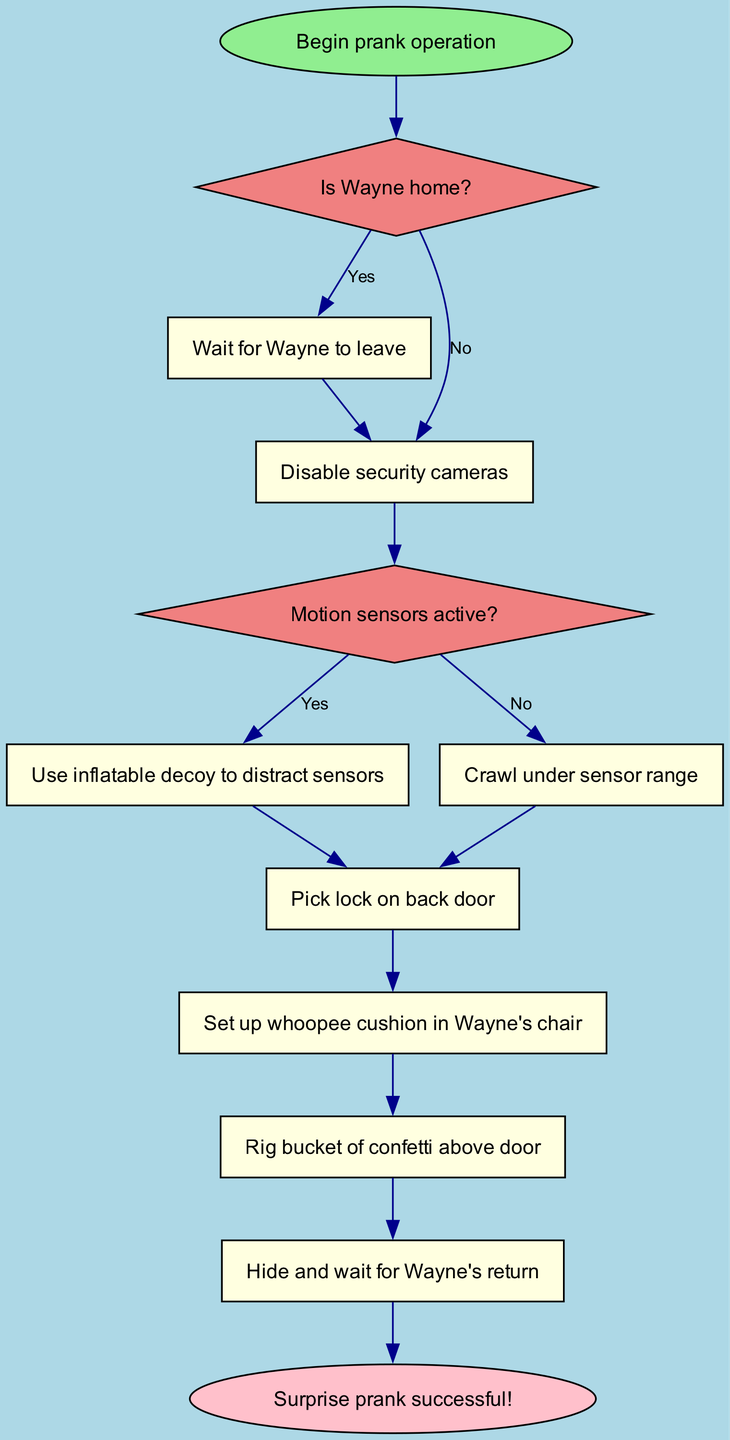What is the first action to take if Wayne is home? According to the flowchart, if Wayne is home, it leads to the first decision where the answer is 'Yes'. The next action indicated is to 'Wait for Wayne to leave'.
Answer: Wait for Wayne to leave What action comes after disabling security cameras? After the action of disabling security cameras, the flowchart directs to the second decision node, which asks if motion sensors are active. Therefore, the action that comes after is 'Disable security cameras'.
Answer: Disable security cameras How many action nodes are present in the flowchart? Upon counting the nodes in the diagram designated as actions, we find eight action nodes identified sequentially within the flowchart.
Answer: Eight What happens if motion sensors are not active? If the motion sensors are not active (answer 'No' at the decision), the flowchart indicates that the next step is to 'Crawl under sensor range'.
Answer: Crawl under sensor range What is the final action before the surprise is executed? The last action that occurs before the flowchart reaches the conclusion is 'Hide and wait for Wayne's return', as this is the action before reaching the end node of the flowchart.
Answer: Hide and wait for Wayne's return 